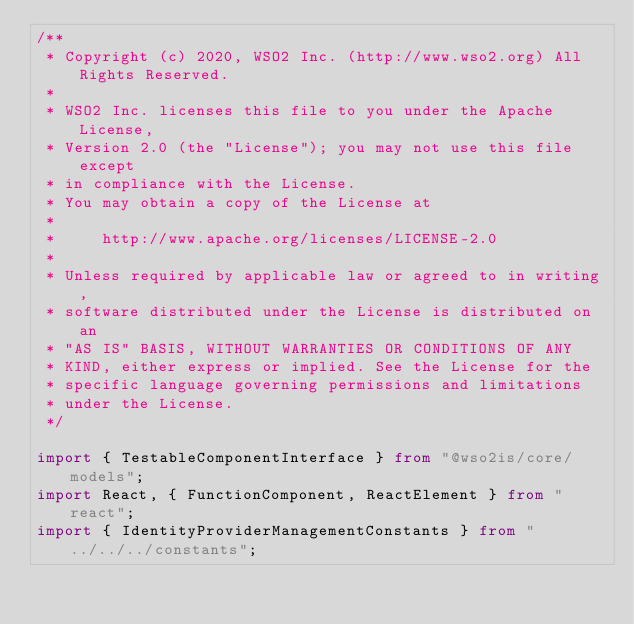Convert code to text. <code><loc_0><loc_0><loc_500><loc_500><_TypeScript_>/**
 * Copyright (c) 2020, WSO2 Inc. (http://www.wso2.org) All Rights Reserved.
 *
 * WSO2 Inc. licenses this file to you under the Apache License,
 * Version 2.0 (the "License"); you may not use this file except
 * in compliance with the License.
 * You may obtain a copy of the License at
 *
 *     http://www.apache.org/licenses/LICENSE-2.0
 *
 * Unless required by applicable law or agreed to in writing,
 * software distributed under the License is distributed on an
 * "AS IS" BASIS, WITHOUT WARRANTIES OR CONDITIONS OF ANY
 * KIND, either express or implied. See the License for the
 * specific language governing permissions and limitations
 * under the License.
 */

import { TestableComponentInterface } from "@wso2is/core/models";
import React, { FunctionComponent, ReactElement } from "react";
import { IdentityProviderManagementConstants } from "../../../constants";</code> 